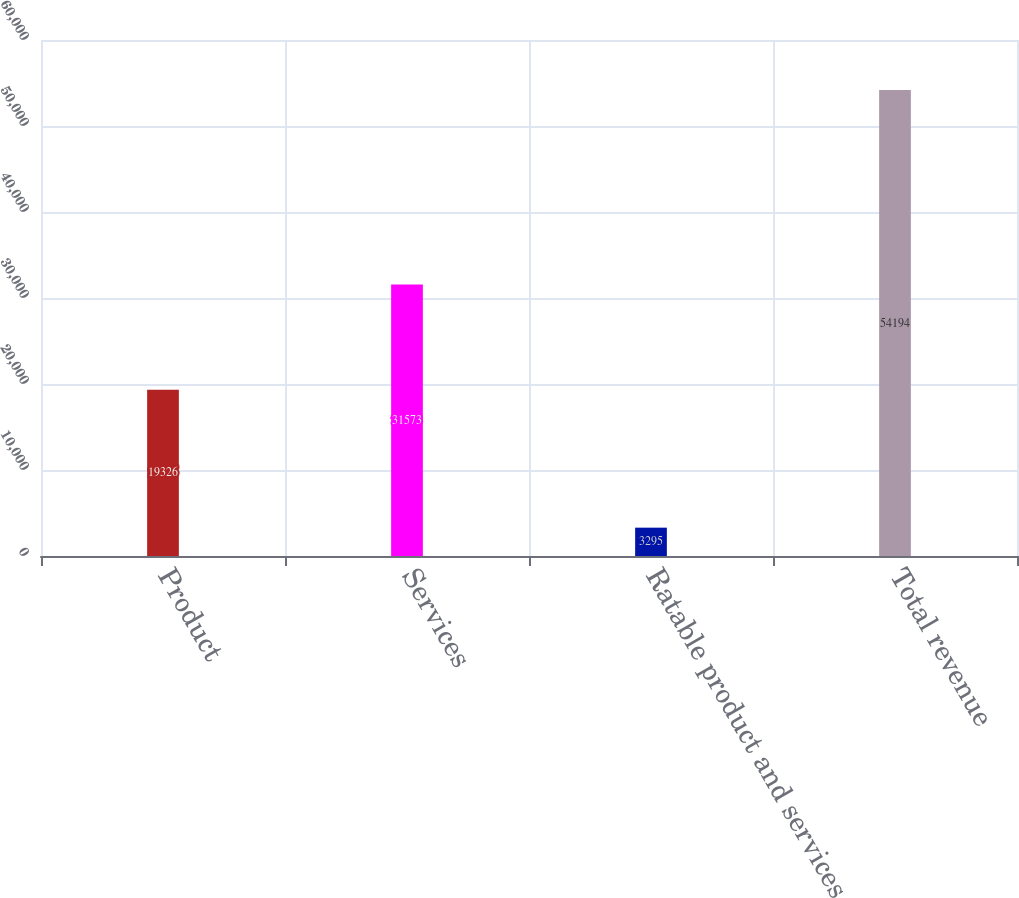<chart> <loc_0><loc_0><loc_500><loc_500><bar_chart><fcel>Product<fcel>Services<fcel>Ratable product and services<fcel>Total revenue<nl><fcel>19326<fcel>31573<fcel>3295<fcel>54194<nl></chart> 